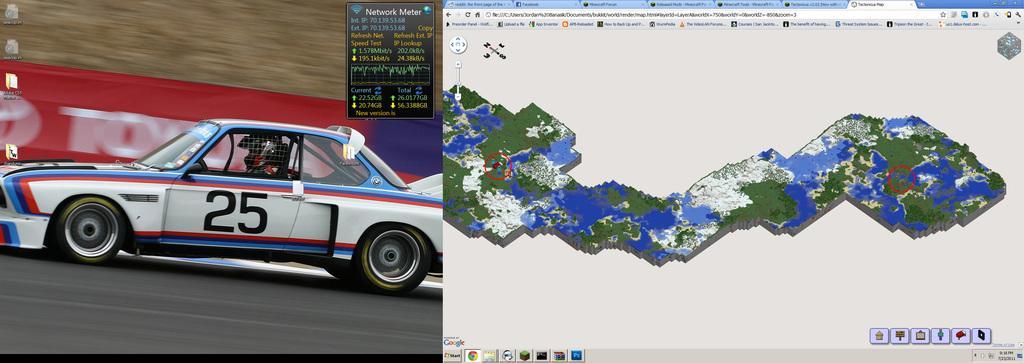How would you summarize this image in a sentence or two? In this picture there are screenshots in the image, which contains a sports car and an aerial view in it. 